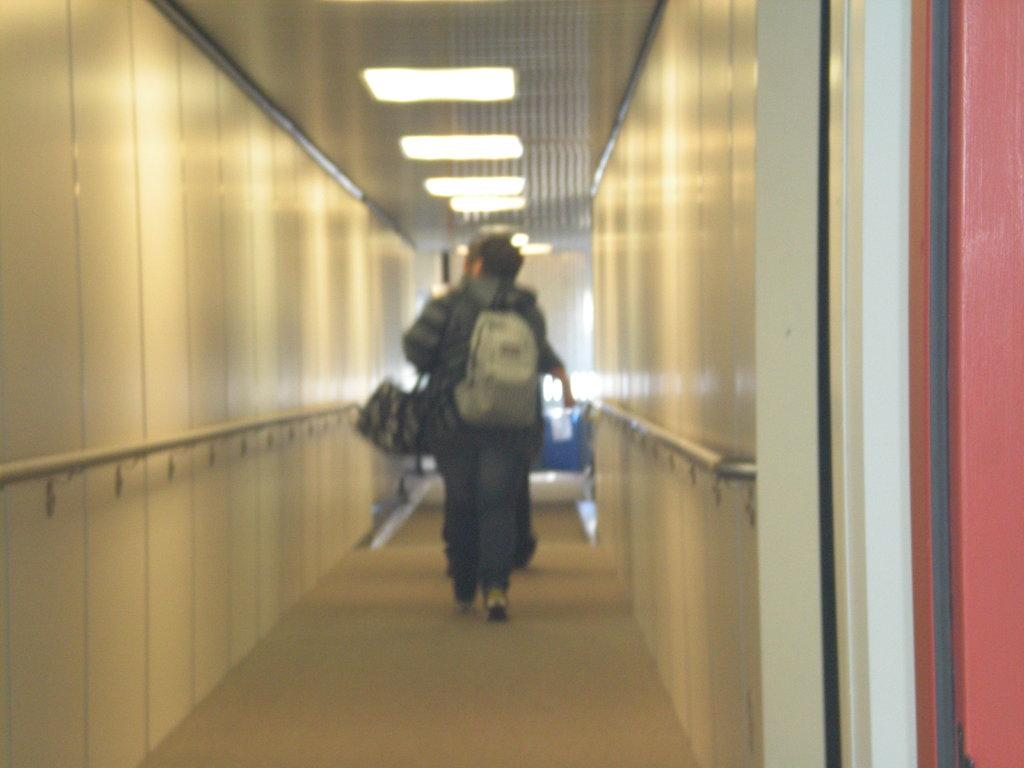What is the main subject of the image? There is a person in the image. What is the person holding? The person is holding a bag. What is the person doing in the image? The person is walking. What can be seen at the top of the image? There are ceiling lights visible in the image. Where are the ceiling lights located in the image? The ceiling lights are at the top of the image. What is attached to the wall in the image? There is a folder attached to the wall in the image. What is the rate of the person's heartbeat in the image? There is no information about the person's heartbeat in the image, so it cannot be determined. 